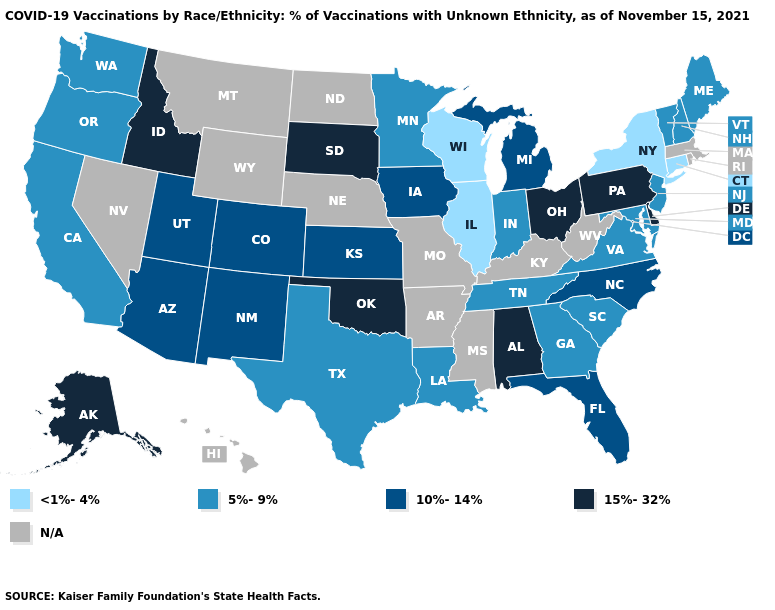What is the value of Illinois?
Be succinct. <1%-4%. Does the map have missing data?
Quick response, please. Yes. Does Wisconsin have the lowest value in the MidWest?
Answer briefly. Yes. What is the lowest value in the West?
Keep it brief. 5%-9%. Which states have the lowest value in the MidWest?
Concise answer only. Illinois, Wisconsin. Which states have the lowest value in the Northeast?
Keep it brief. Connecticut, New York. What is the value of Hawaii?
Be succinct. N/A. Does Illinois have the lowest value in the MidWest?
Keep it brief. Yes. What is the lowest value in the USA?
Concise answer only. <1%-4%. Name the states that have a value in the range <1%-4%?
Quick response, please. Connecticut, Illinois, New York, Wisconsin. Name the states that have a value in the range 5%-9%?
Answer briefly. California, Georgia, Indiana, Louisiana, Maine, Maryland, Minnesota, New Hampshire, New Jersey, Oregon, South Carolina, Tennessee, Texas, Vermont, Virginia, Washington. Does the first symbol in the legend represent the smallest category?
Write a very short answer. Yes. Among the states that border Delaware , does New Jersey have the highest value?
Give a very brief answer. No. What is the value of Ohio?
Quick response, please. 15%-32%. 